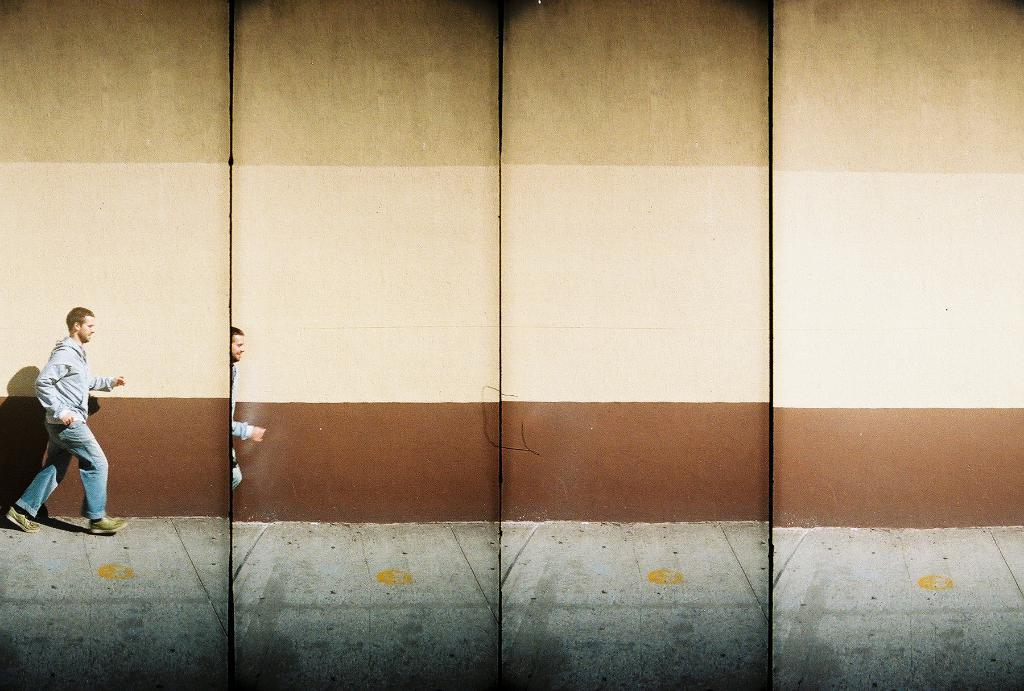What is the person in the image doing? The person is running in the image. On what surface is the person running? The person is running on a road. What can be seen in the background of the image? There is a wall in the background of the image. What type of scarf is the person wearing while running in the image? There is no scarf visible in the image; the person is running without any apparent clothing or accessories. 